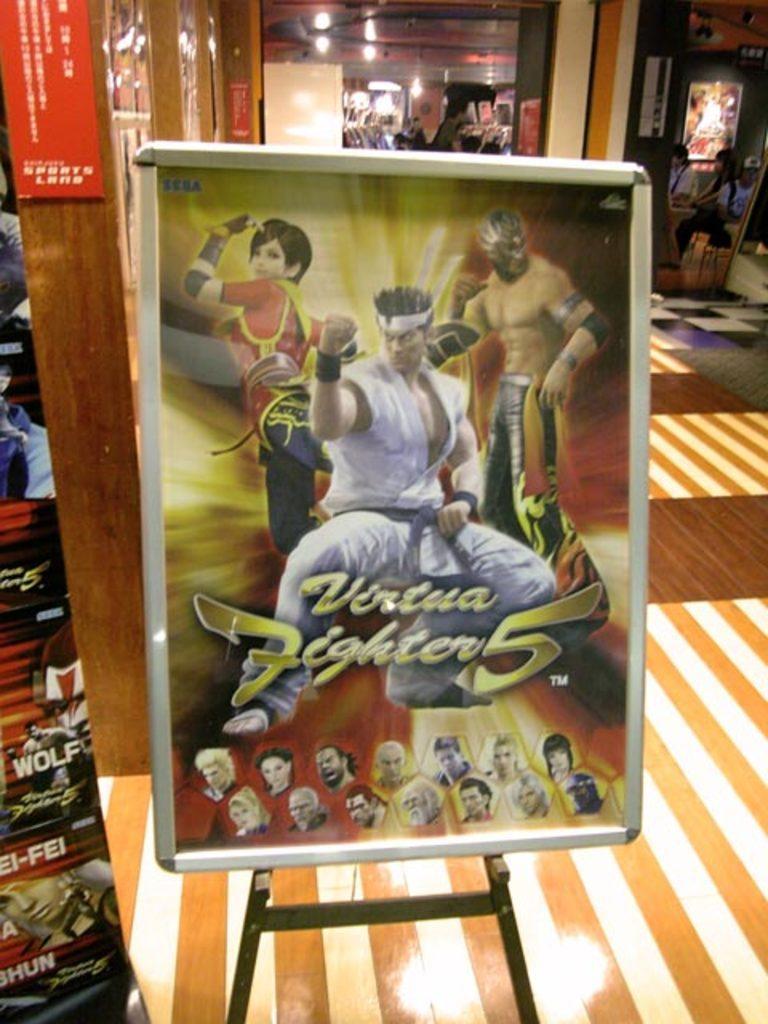How would you summarize this image in a sentence or two? This picture show about the cartoon board placed in the front of the image. Behind there are some girls sitting and above them we can see other posts on the wall. 